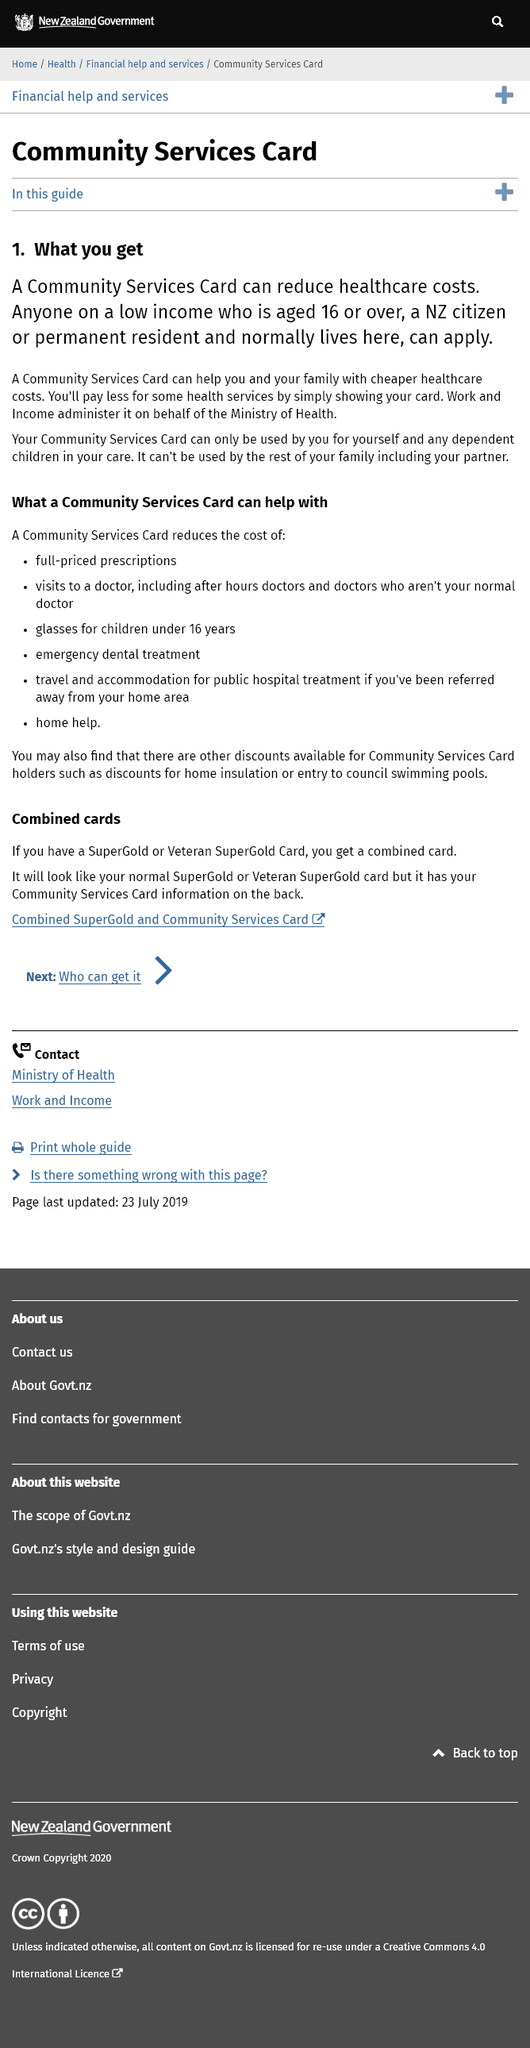Specify some key components in this picture. To obtain a Community Services Card, you must be at least 16 years of age. The Community Services Card cannot be used by a partner. Yes, individuals with low income can use the Community Services Card for their children. 